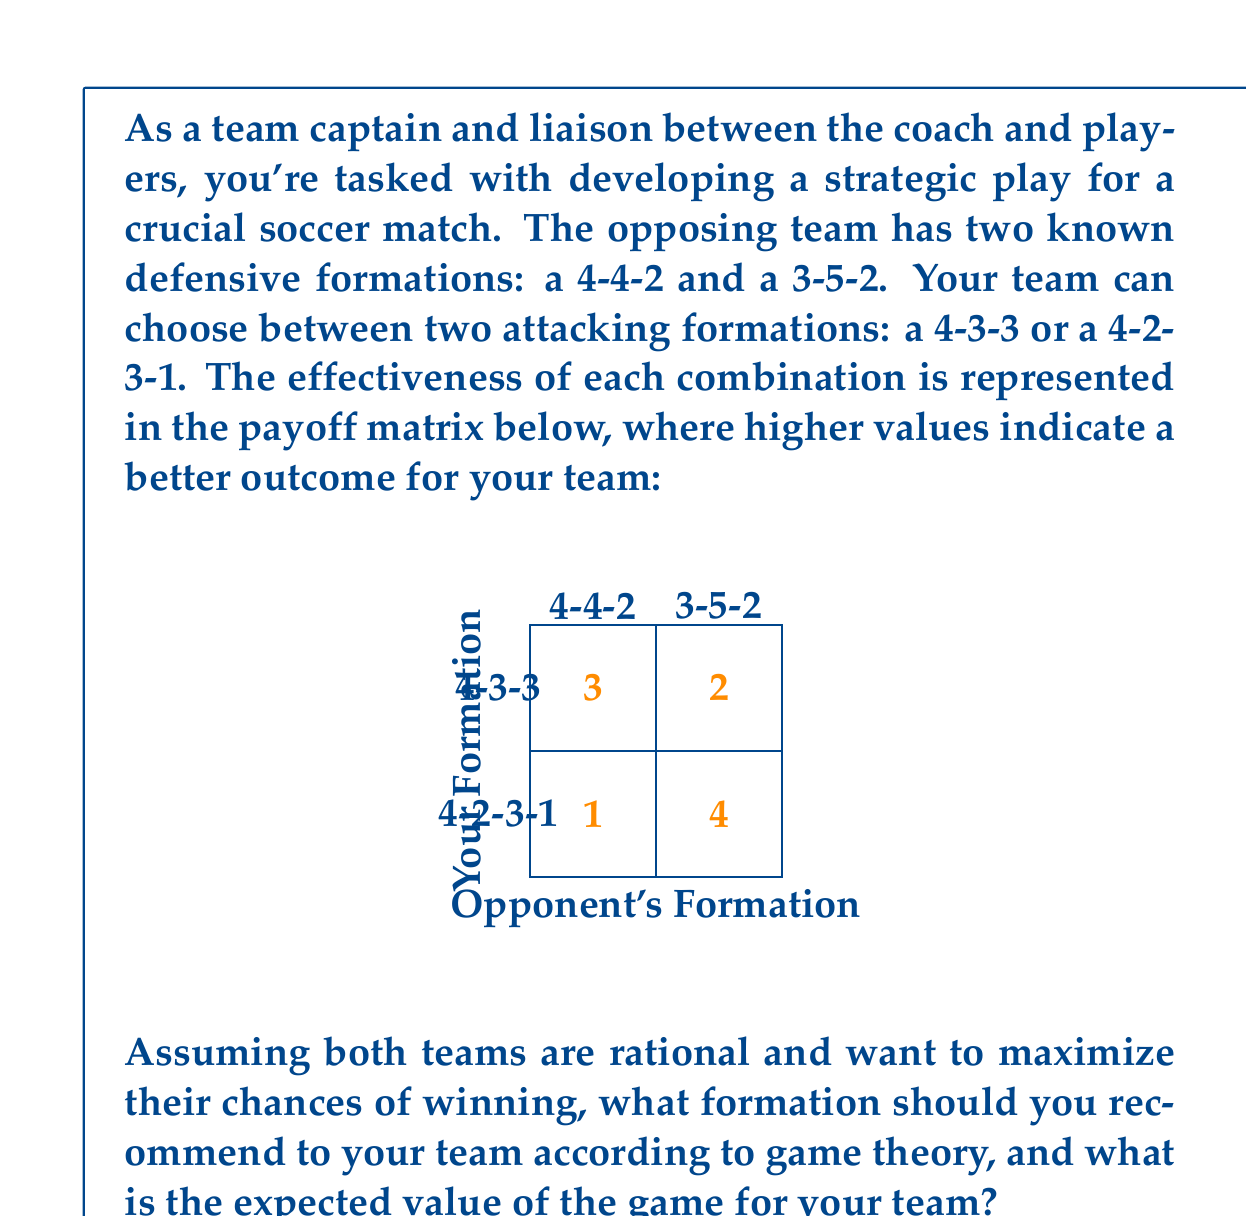Give your solution to this math problem. To solve this problem, we'll use the minimax theorem from game theory. The steps are as follows:

1) First, we need to identify the minimax and maximin strategies:

   For your team (row player):
   4-3-3: min(3,2) = 2
   4-2-3-1: min(1,4) = 1
   Maximin = max(2,1) = 2

   For the opponent (column player):
   4-4-2: max(3,1) = 3
   3-5-2: max(2,4) = 4
   Minimax = min(3,4) = 3

2) Since the maximin ≠ minimax, there's no pure strategy equilibrium. We need to find a mixed strategy.

3) Let's define probabilities:
   p = probability of choosing 4-3-3
   1-p = probability of choosing 4-2-3-1
   q = probability of opponent choosing 4-4-2
   1-q = probability of opponent choosing 3-5-2

4) Set up equations for expected values:
   For 4-4-2: 3p + 1(1-p) = v
   For 3-5-2: 2p + 4(1-p) = v
   Where v is the value of the game.

5) Solve the equations:
   3p + 1 - p = 2p + 4 - 4p
   2p + 1 = -2p + 4
   4p = 3
   p = 3/4

6) The optimal strategy for your team is to play 4-3-3 with probability 3/4 and 4-2-3-1 with probability 1/4.

7) To find the value of the game, substitute p = 3/4 into either equation:
   v = 3(3/4) + 1(1/4) = 9/4 + 1/4 = 2.5

Therefore, you should recommend a mixed strategy to your team, playing 4-3-3 formation 75% of the time and 4-2-3-1 formation 25% of the time. The expected value of the game for your team is 2.5.
Answer: Mixed strategy: 75% 4-3-3, 25% 4-2-3-1. Expected value: 2.5. 